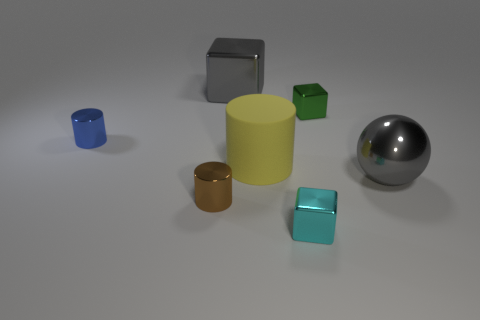Add 2 brown metallic cylinders. How many objects exist? 9 Subtract all blocks. How many objects are left? 4 Add 3 big brown cylinders. How many big brown cylinders exist? 3 Subtract 0 green spheres. How many objects are left? 7 Subtract all tiny brown things. Subtract all gray shiny balls. How many objects are left? 5 Add 2 rubber things. How many rubber things are left? 3 